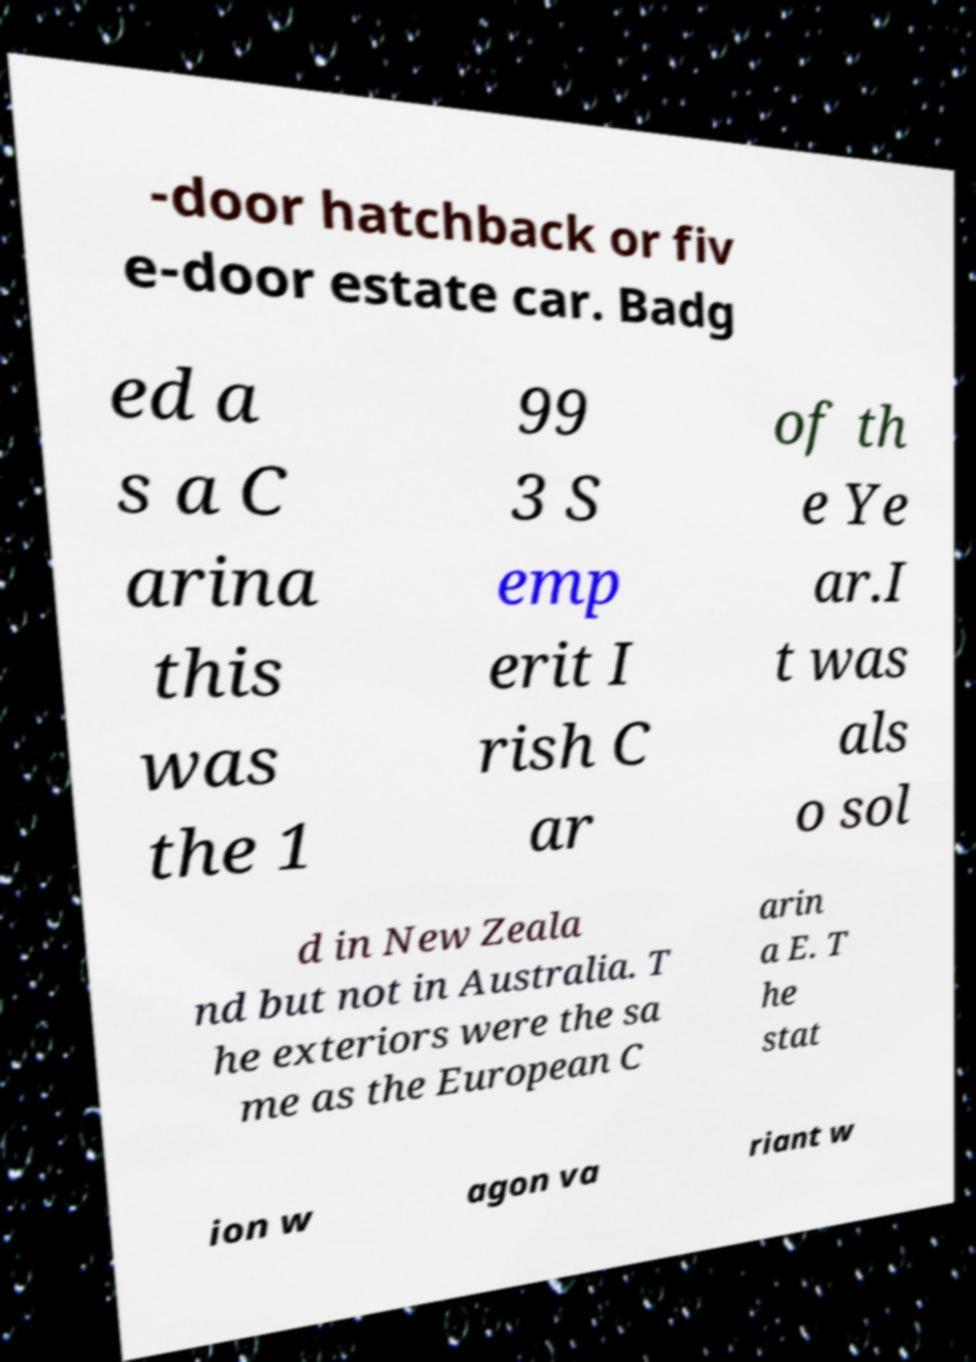For documentation purposes, I need the text within this image transcribed. Could you provide that? -door hatchback or fiv e-door estate car. Badg ed a s a C arina this was the 1 99 3 S emp erit I rish C ar of th e Ye ar.I t was als o sol d in New Zeala nd but not in Australia. T he exteriors were the sa me as the European C arin a E. T he stat ion w agon va riant w 